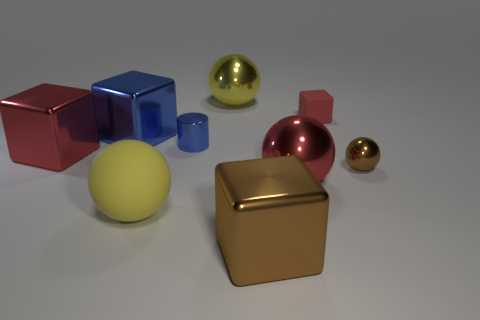What number of big yellow matte objects are there? There is one large yellow matte sphere in the image amidst other colorful objects with various shapes and finishes. 